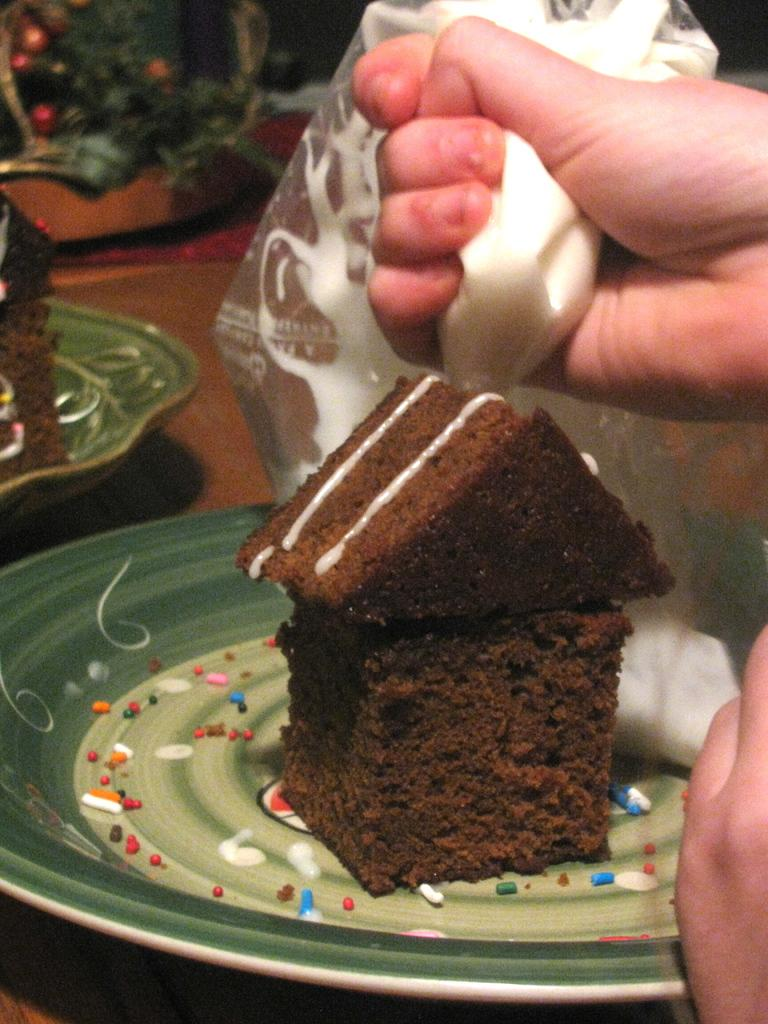What part of a person can be seen in the image? There are hands of a person visible in the image. What is the person holding in the image? The person is holding an object. What can be found on the plates in the image? There are plates with food items in the image. Can you describe the unspecified objects at the top of the image? Unfortunately, the facts provided do not give any details about the objects at the top of the image. How many tails can be seen on the person in the image? There are no tails visible in the image, as the subject is a person's hands. What type of chairs are present in the image? There is no information about chairs in the provided facts, so we cannot determine if any are present in the image. 